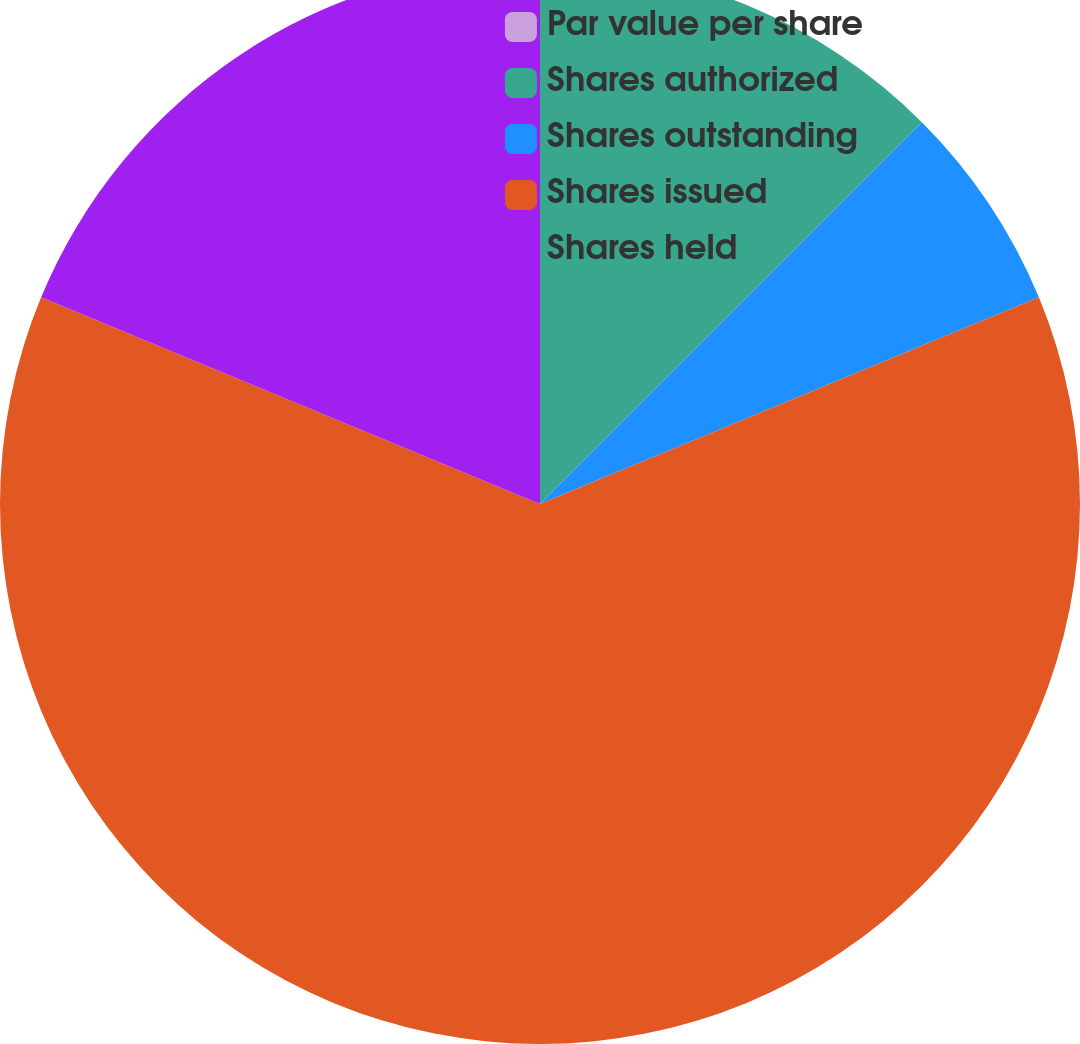Convert chart. <chart><loc_0><loc_0><loc_500><loc_500><pie_chart><fcel>Par value per share<fcel>Shares authorized<fcel>Shares outstanding<fcel>Shares issued<fcel>Shares held<nl><fcel>0.0%<fcel>12.5%<fcel>6.25%<fcel>62.5%<fcel>18.75%<nl></chart> 